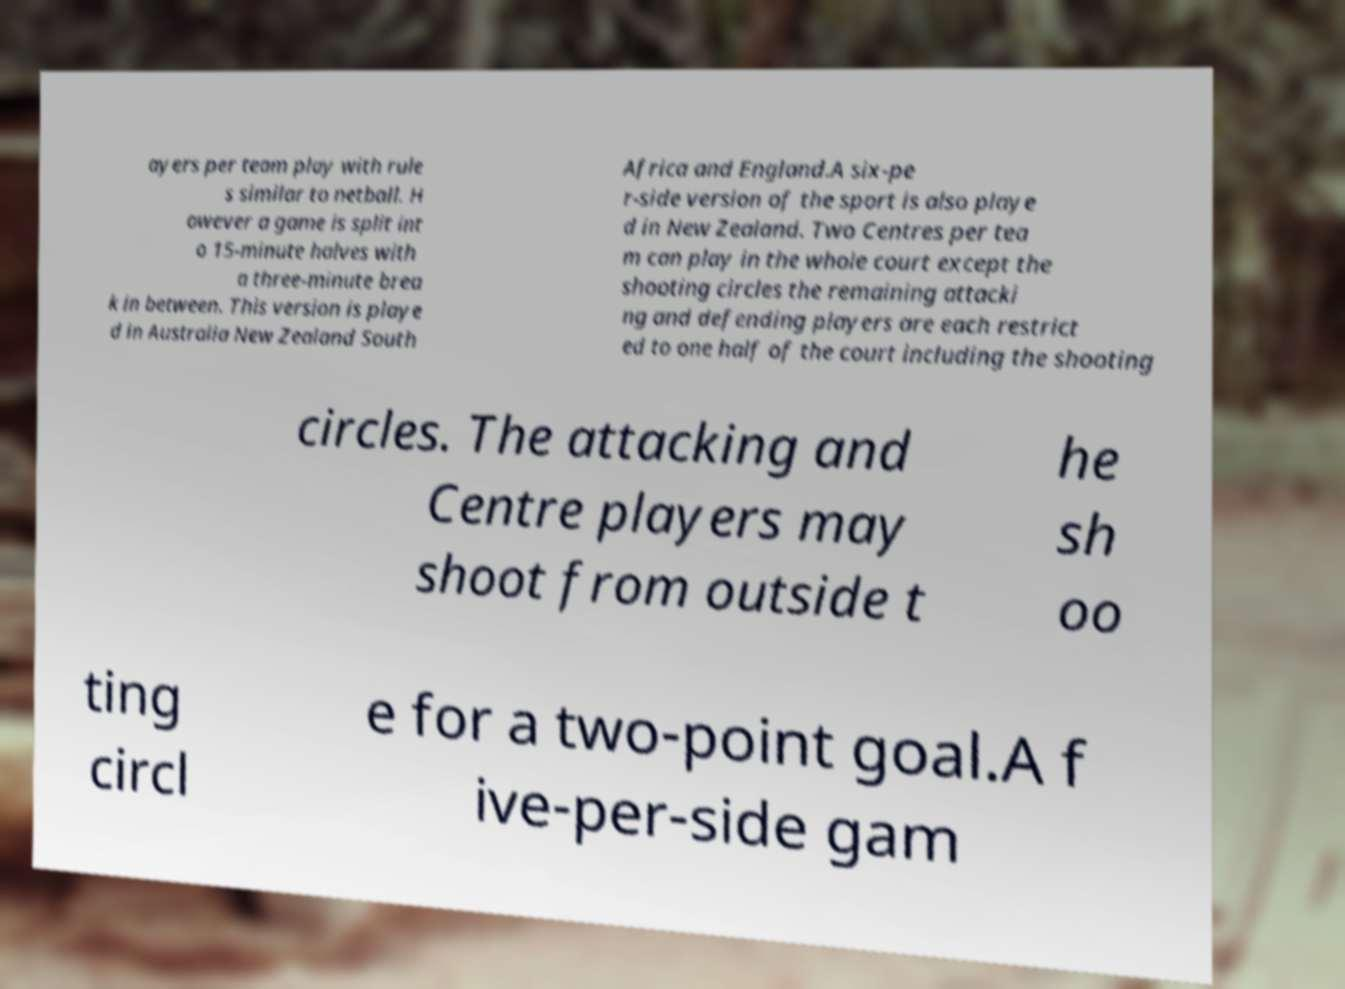Please identify and transcribe the text found in this image. ayers per team play with rule s similar to netball. H owever a game is split int o 15-minute halves with a three-minute brea k in between. This version is playe d in Australia New Zealand South Africa and England.A six-pe r-side version of the sport is also playe d in New Zealand. Two Centres per tea m can play in the whole court except the shooting circles the remaining attacki ng and defending players are each restrict ed to one half of the court including the shooting circles. The attacking and Centre players may shoot from outside t he sh oo ting circl e for a two-point goal.A f ive-per-side gam 